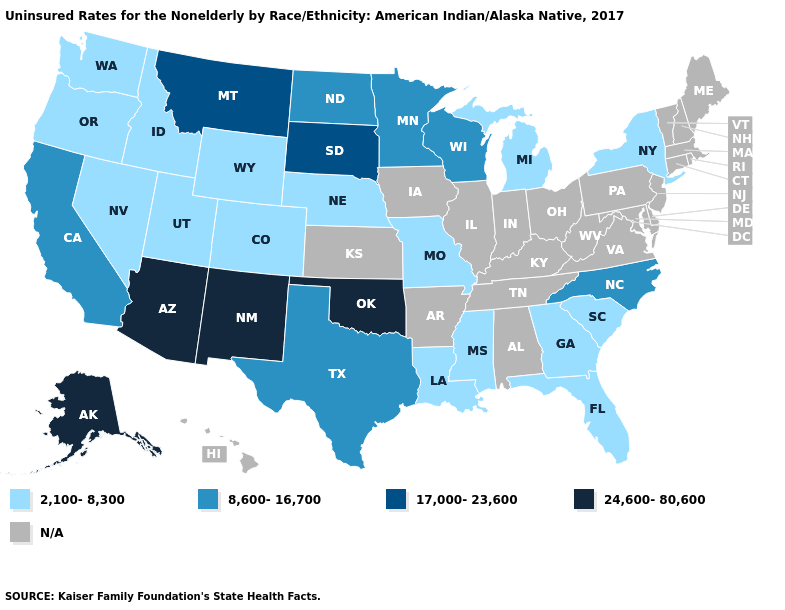Which states hav the highest value in the Northeast?
Short answer required. New York. Which states have the lowest value in the West?
Answer briefly. Colorado, Idaho, Nevada, Oregon, Utah, Washington, Wyoming. What is the lowest value in the South?
Answer briefly. 2,100-8,300. What is the value of Indiana?
Write a very short answer. N/A. Name the states that have a value in the range 2,100-8,300?
Concise answer only. Colorado, Florida, Georgia, Idaho, Louisiana, Michigan, Mississippi, Missouri, Nebraska, Nevada, New York, Oregon, South Carolina, Utah, Washington, Wyoming. What is the value of West Virginia?
Give a very brief answer. N/A. Among the states that border Montana , which have the highest value?
Keep it brief. South Dakota. Name the states that have a value in the range 2,100-8,300?
Short answer required. Colorado, Florida, Georgia, Idaho, Louisiana, Michigan, Mississippi, Missouri, Nebraska, Nevada, New York, Oregon, South Carolina, Utah, Washington, Wyoming. What is the value of Ohio?
Quick response, please. N/A. What is the value of North Carolina?
Quick response, please. 8,600-16,700. Does the map have missing data?
Keep it brief. Yes. What is the value of Vermont?
Concise answer only. N/A. Does the first symbol in the legend represent the smallest category?
Short answer required. Yes. 